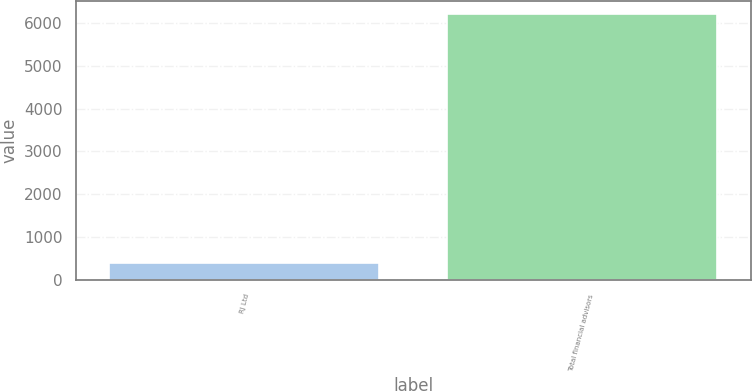<chart> <loc_0><loc_0><loc_500><loc_500><bar_chart><fcel>RJ Ltd<fcel>Total financial advisors<nl><fcel>406<fcel>6197<nl></chart> 